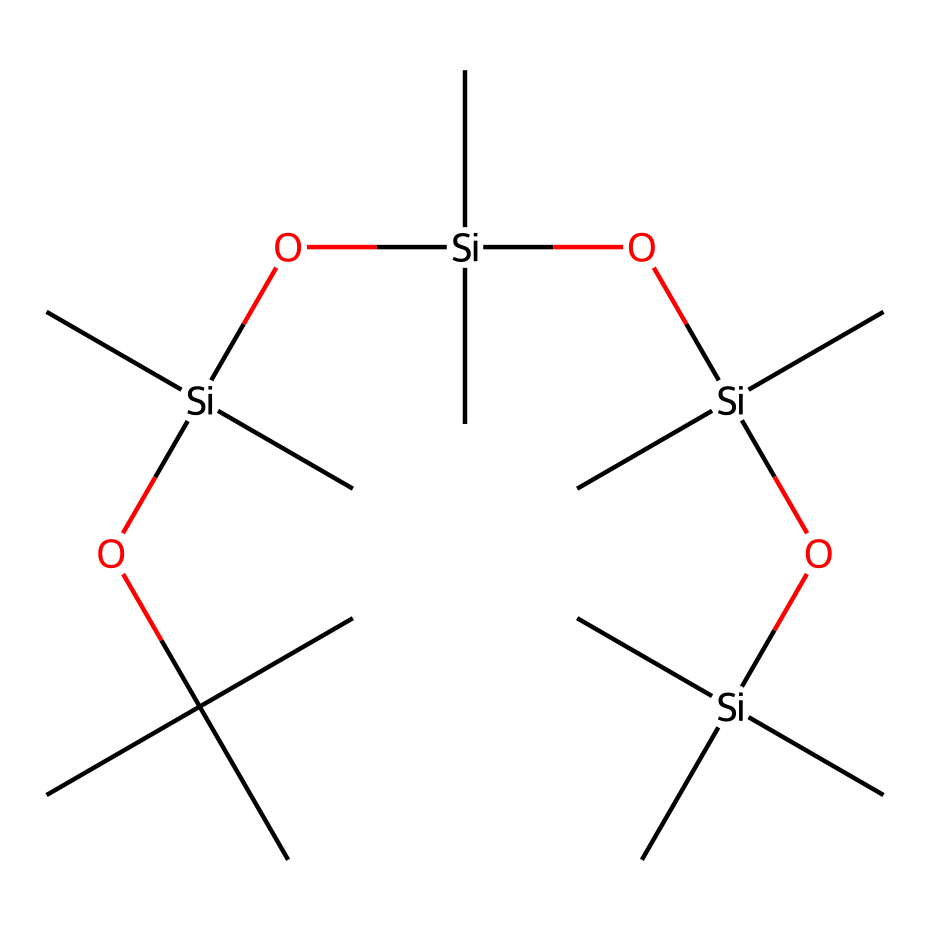How many silicon atoms are present in this structure? The SMILES representation indicates the presence of four silicon atoms, denoted by the [Si] symbols in the sequence.
Answer: four What functional groups are present in this chemical structure? The chemical includes hydroxyl groups (-OH) indicated by 'O' and a methoxy group (-O-C) present as part of the structure, giving it lubrication properties.
Answer: hydroxyl and methoxy What is the primary element in this structure? The predominant element in the SMILES notation is silicon, which appears multiple times, making it the primary element of this chemical.
Answer: silicon How many carbon atoms are in this silicone-based lubricant? By carefully counting the number of 'C' symbols in the SMILES, there are 18 carbon atoms in total, which are attached to silicon and other functional groups.
Answer: eighteen What type of chemical is this? This chemical is classified as a silicone-based lubricant due to its silicon backbone and the presence of organic functional groups enhancing its lubricating properties.
Answer: silicone-based lubricant What is the likely physical state of this chemical at room temperature? Given the structure, which contains long carbon chains and silicon atoms, this compound is likely to be a viscous liquid or semi-solid at room temperature, typical for lubricants.
Answer: viscous liquid 